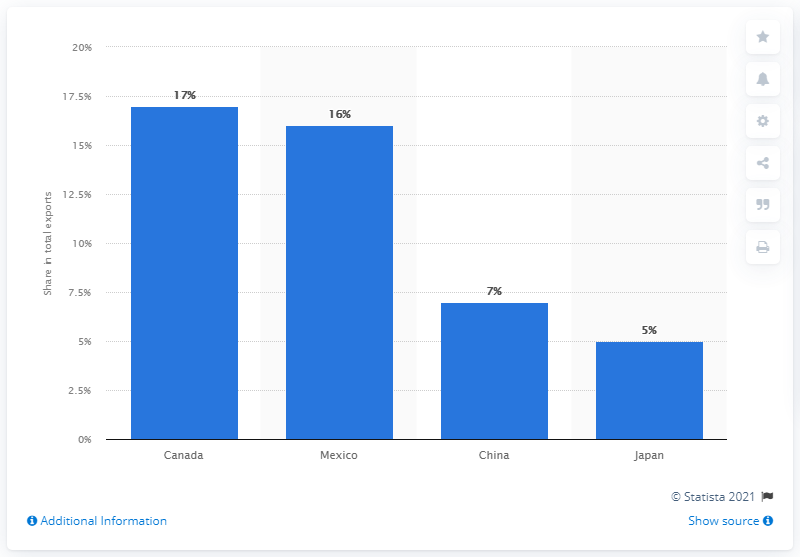Indicate a few pertinent items in this graphic. In 2019, Canada was the most important export partner of the United States. 